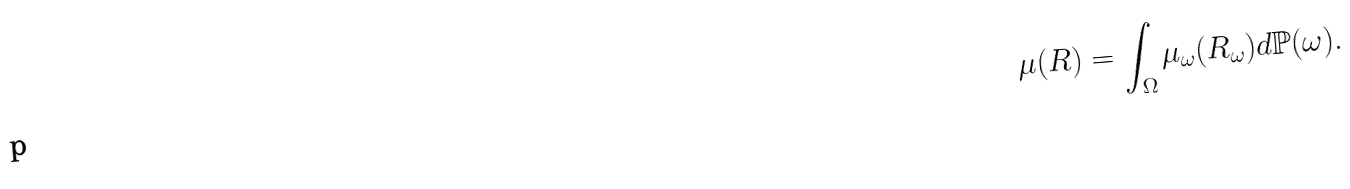Convert formula to latex. <formula><loc_0><loc_0><loc_500><loc_500>\mu ( R ) = \int _ { \Omega } \mu _ { \omega } ( R _ { \omega } ) d \mathbb { P } ( \omega ) .</formula> 